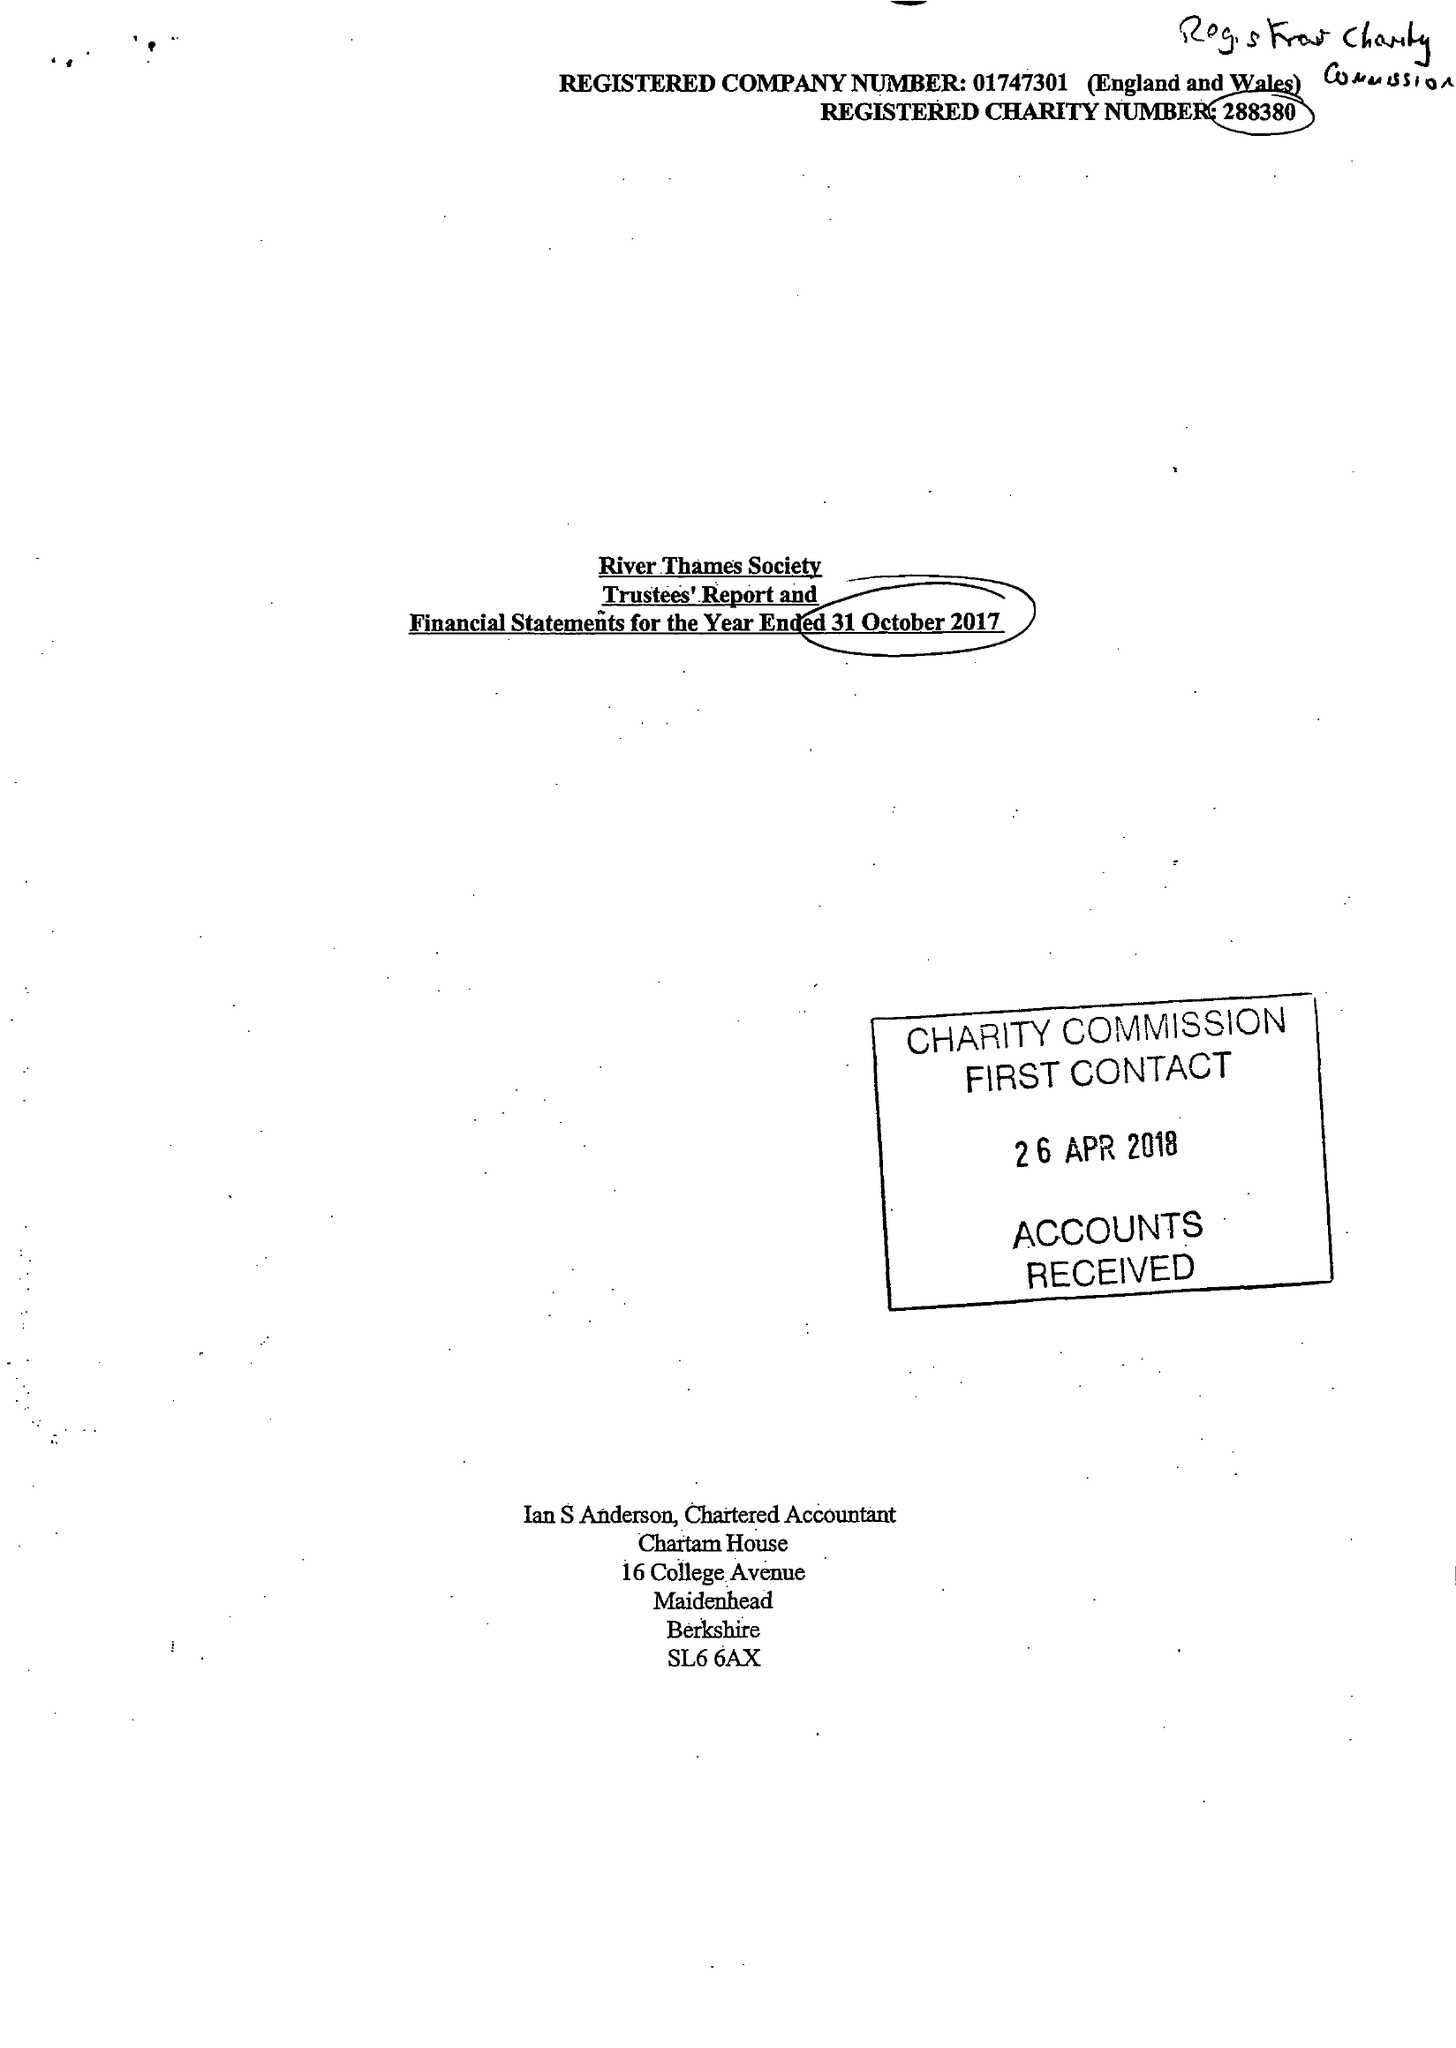What is the value for the charity_name?
Answer the question using a single word or phrase. River Thames Society 